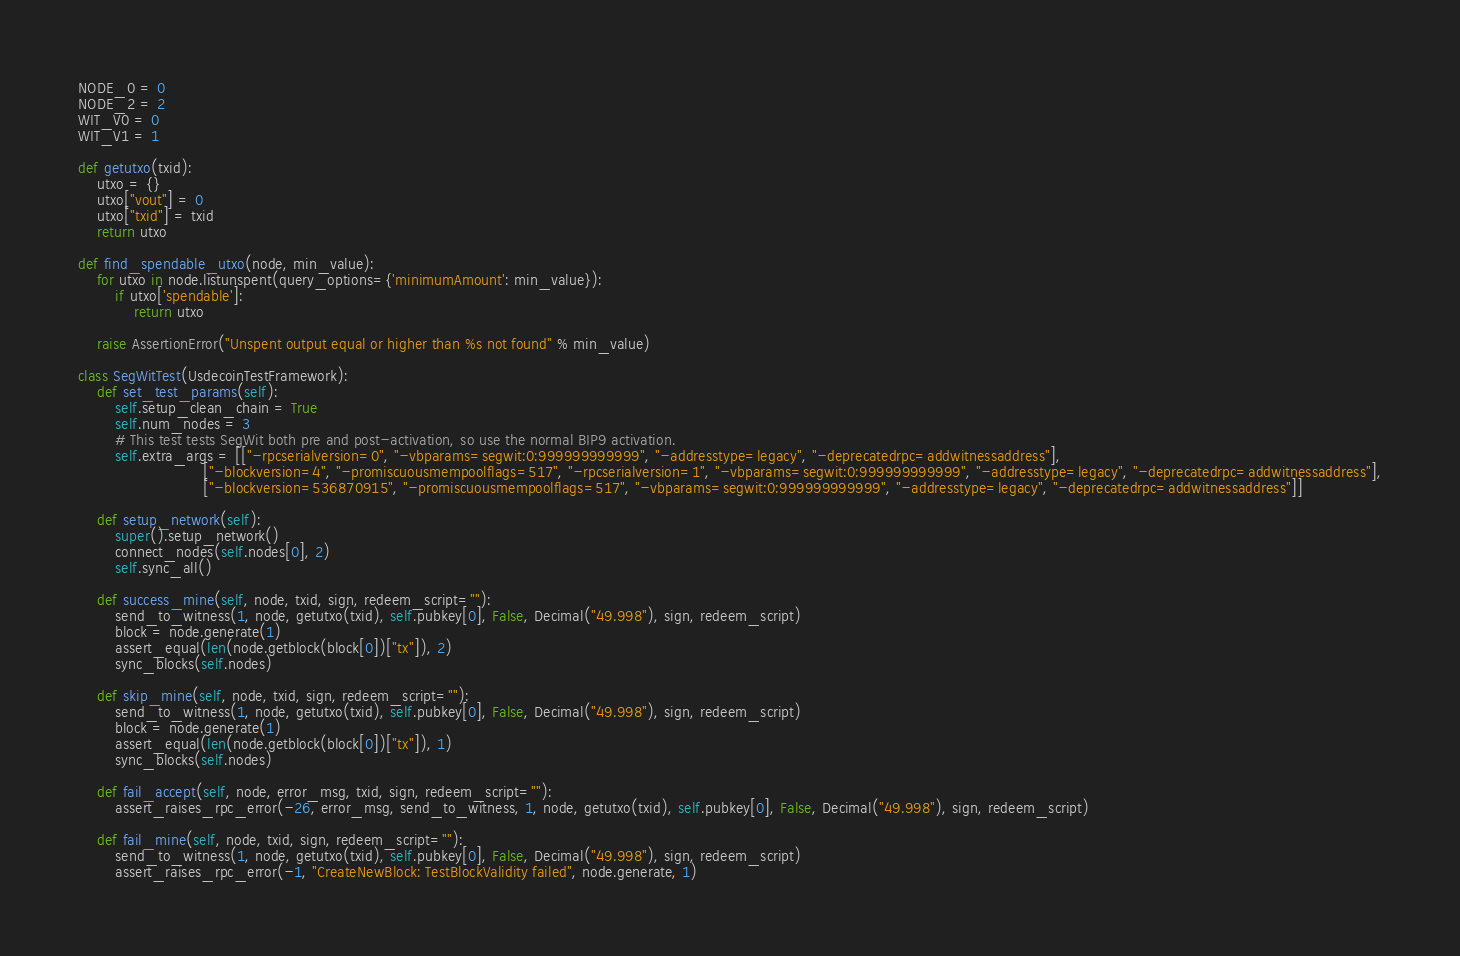Convert code to text. <code><loc_0><loc_0><loc_500><loc_500><_Python_>NODE_0 = 0
NODE_2 = 2
WIT_V0 = 0
WIT_V1 = 1

def getutxo(txid):
    utxo = {}
    utxo["vout"] = 0
    utxo["txid"] = txid
    return utxo

def find_spendable_utxo(node, min_value):
    for utxo in node.listunspent(query_options={'minimumAmount': min_value}):
        if utxo['spendable']:
            return utxo

    raise AssertionError("Unspent output equal or higher than %s not found" % min_value)

class SegWitTest(UsdecoinTestFramework):
    def set_test_params(self):
        self.setup_clean_chain = True
        self.num_nodes = 3
        # This test tests SegWit both pre and post-activation, so use the normal BIP9 activation.
        self.extra_args = [["-rpcserialversion=0", "-vbparams=segwit:0:999999999999", "-addresstype=legacy", "-deprecatedrpc=addwitnessaddress"],
                           ["-blockversion=4", "-promiscuousmempoolflags=517", "-rpcserialversion=1", "-vbparams=segwit:0:999999999999", "-addresstype=legacy", "-deprecatedrpc=addwitnessaddress"],
                           ["-blockversion=536870915", "-promiscuousmempoolflags=517", "-vbparams=segwit:0:999999999999", "-addresstype=legacy", "-deprecatedrpc=addwitnessaddress"]]

    def setup_network(self):
        super().setup_network()
        connect_nodes(self.nodes[0], 2)
        self.sync_all()

    def success_mine(self, node, txid, sign, redeem_script=""):
        send_to_witness(1, node, getutxo(txid), self.pubkey[0], False, Decimal("49.998"), sign, redeem_script)
        block = node.generate(1)
        assert_equal(len(node.getblock(block[0])["tx"]), 2)
        sync_blocks(self.nodes)

    def skip_mine(self, node, txid, sign, redeem_script=""):
        send_to_witness(1, node, getutxo(txid), self.pubkey[0], False, Decimal("49.998"), sign, redeem_script)
        block = node.generate(1)
        assert_equal(len(node.getblock(block[0])["tx"]), 1)
        sync_blocks(self.nodes)

    def fail_accept(self, node, error_msg, txid, sign, redeem_script=""):
        assert_raises_rpc_error(-26, error_msg, send_to_witness, 1, node, getutxo(txid), self.pubkey[0], False, Decimal("49.998"), sign, redeem_script)

    def fail_mine(self, node, txid, sign, redeem_script=""):
        send_to_witness(1, node, getutxo(txid), self.pubkey[0], False, Decimal("49.998"), sign, redeem_script)
        assert_raises_rpc_error(-1, "CreateNewBlock: TestBlockValidity failed", node.generate, 1)</code> 